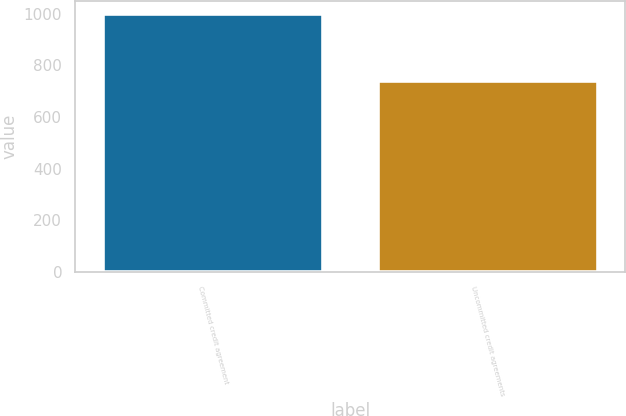Convert chart to OTSL. <chart><loc_0><loc_0><loc_500><loc_500><bar_chart><fcel>Committed credit agreement<fcel>Uncommitted credit agreements<nl><fcel>1000<fcel>740.3<nl></chart> 